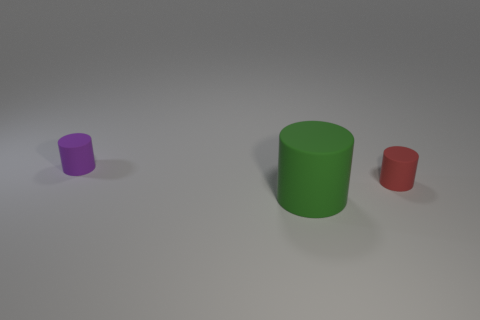Is there any other thing that is made of the same material as the purple object? Based on the visual clues in the image, it appears that the green and red objects are made of the same material as the purple object, likely a type of plastic or a digitally rendered material if this is a computer-generated image. All three show similar matte surfaces and light reflections, which suggest they share the same properties. 